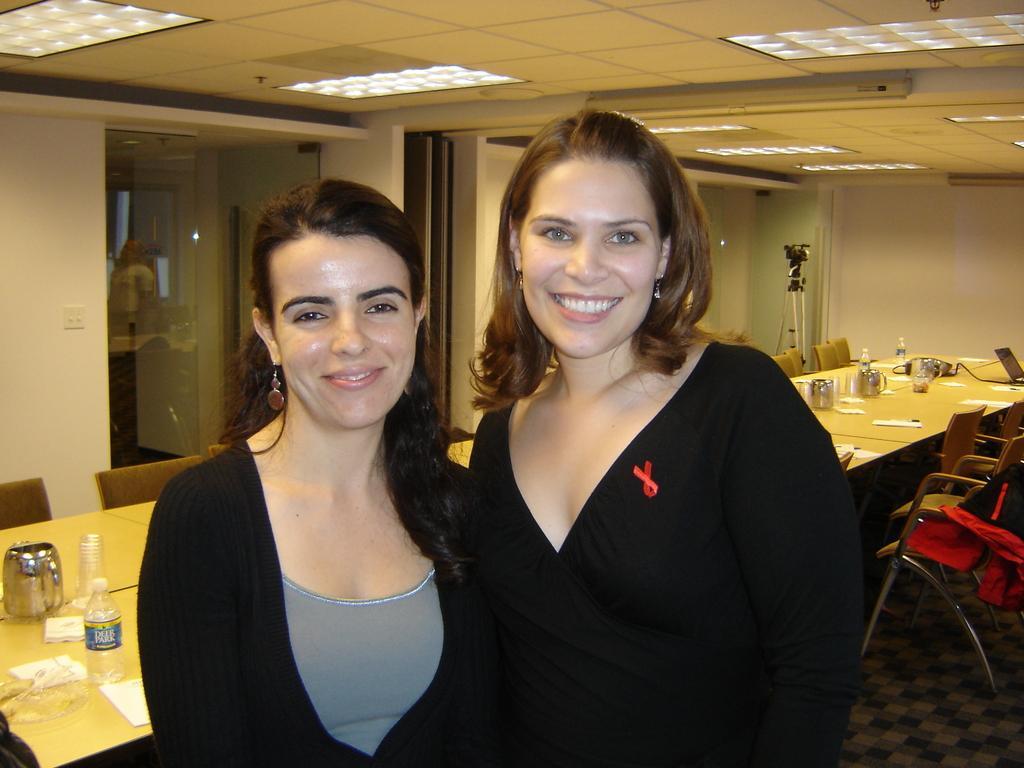In one or two sentences, can you explain what this image depicts? There are two ladies standing side by side. They both are wearing black dress. Behind them there is a big table. On the table there are jugs, bottles, tissues,chairs and there is a window with the glass. On the top there are some lighting. And there is a video camera on the corner. 